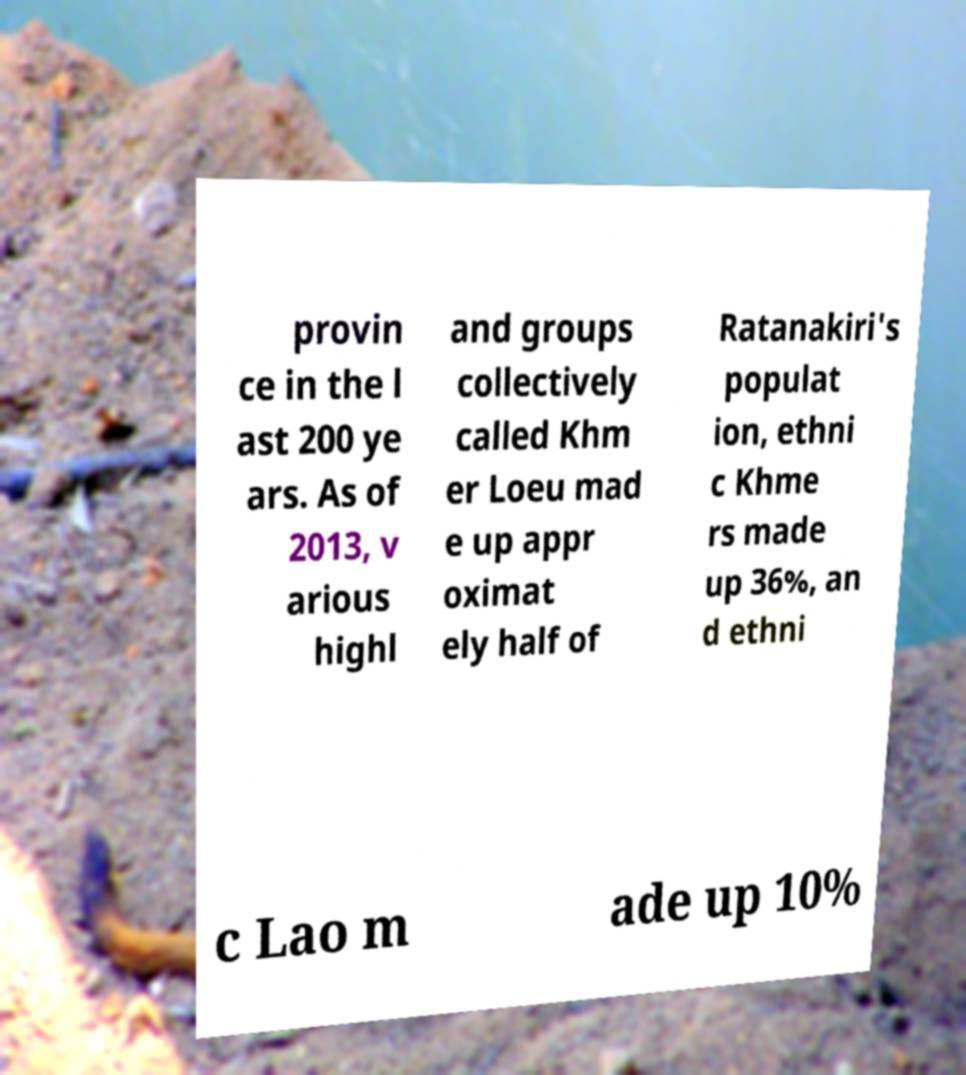Please read and relay the text visible in this image. What does it say? provin ce in the l ast 200 ye ars. As of 2013, v arious highl and groups collectively called Khm er Loeu mad e up appr oximat ely half of Ratanakiri's populat ion, ethni c Khme rs made up 36%, an d ethni c Lao m ade up 10% 